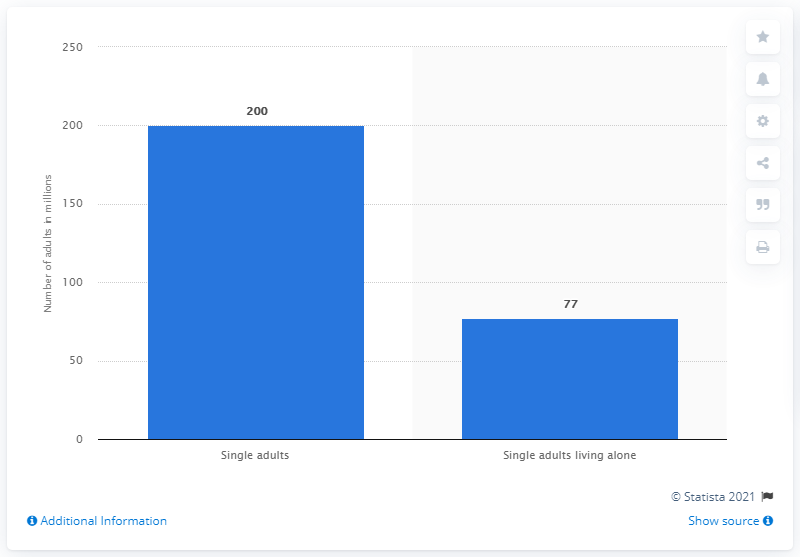Mention a couple of crucial points in this snapshot. In 2018, it is estimated that approximately 200 million single adults lived in China. 